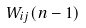<formula> <loc_0><loc_0><loc_500><loc_500>W _ { i j } ( n - 1 )</formula> 